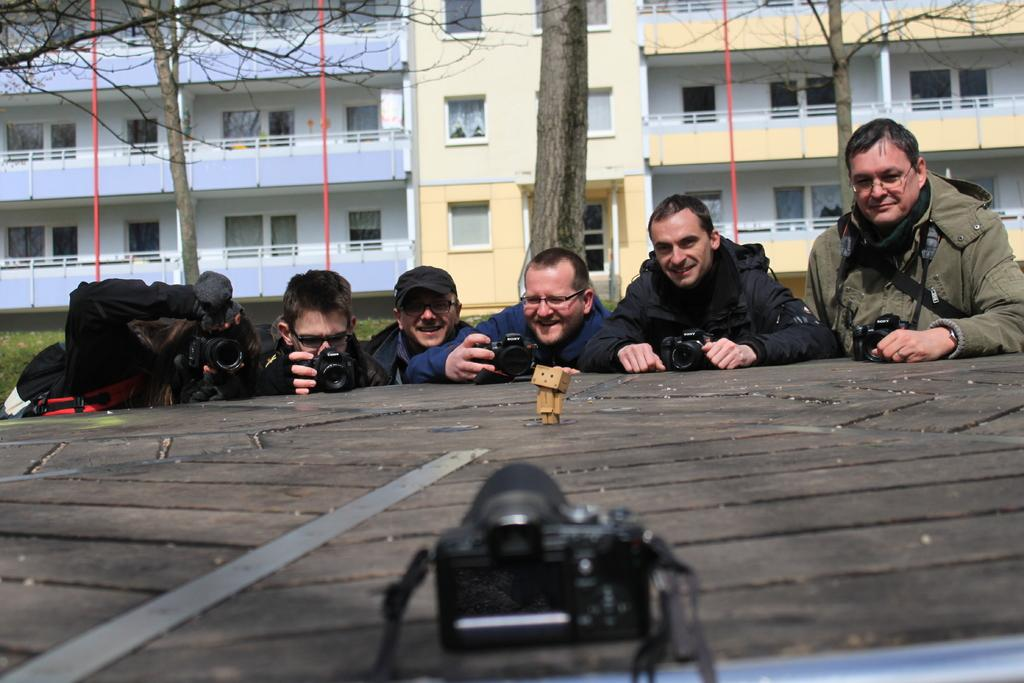Who or what is present in the image? There are people in the image. What are the people holding? The people are holding cameras. What is located in front of the people? There is a toy in front of the people. What type of noise is the minister making in the image? There is no minister present in the image, and therefore no such noise can be heard. 